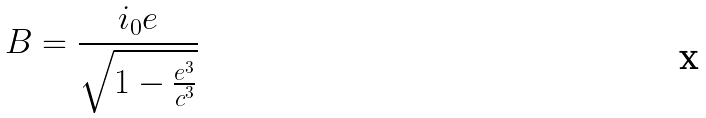Convert formula to latex. <formula><loc_0><loc_0><loc_500><loc_500>B = \frac { i _ { 0 } e } { \sqrt { 1 - \frac { e ^ { 3 } } { c ^ { 3 } } } }</formula> 